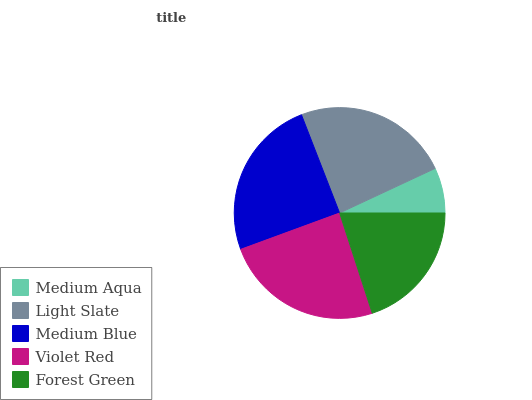Is Medium Aqua the minimum?
Answer yes or no. Yes. Is Medium Blue the maximum?
Answer yes or no. Yes. Is Light Slate the minimum?
Answer yes or no. No. Is Light Slate the maximum?
Answer yes or no. No. Is Light Slate greater than Medium Aqua?
Answer yes or no. Yes. Is Medium Aqua less than Light Slate?
Answer yes or no. Yes. Is Medium Aqua greater than Light Slate?
Answer yes or no. No. Is Light Slate less than Medium Aqua?
Answer yes or no. No. Is Light Slate the high median?
Answer yes or no. Yes. Is Light Slate the low median?
Answer yes or no. Yes. Is Forest Green the high median?
Answer yes or no. No. Is Forest Green the low median?
Answer yes or no. No. 